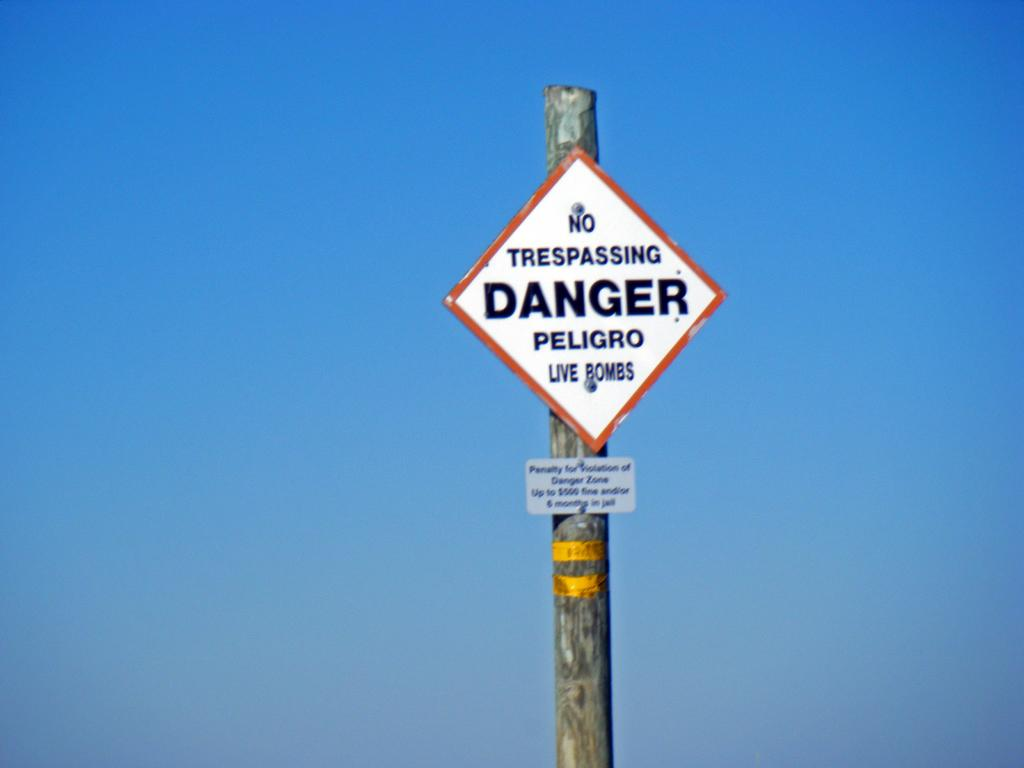<image>
Present a compact description of the photo's key features. A diamond shaped sign on the pole gives a no trespassing warning. 